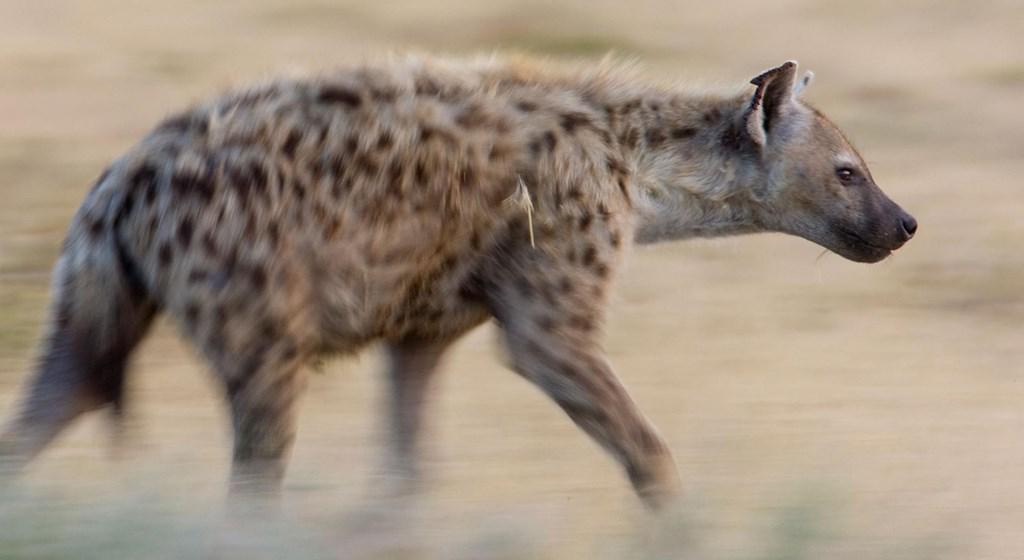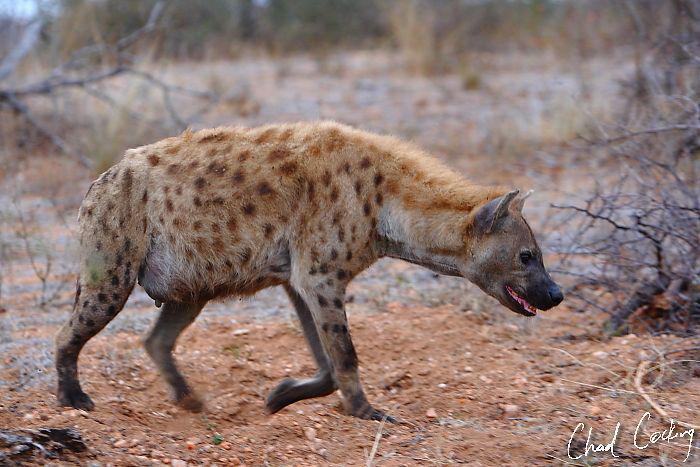The first image is the image on the left, the second image is the image on the right. For the images displayed, is the sentence "An image shows a hyena facing a smaller fox-like animal." factually correct? Answer yes or no. No. The first image is the image on the left, the second image is the image on the right. Analyze the images presented: Is the assertion "A predator and its prey are facing off in the image on the right." valid? Answer yes or no. No. 